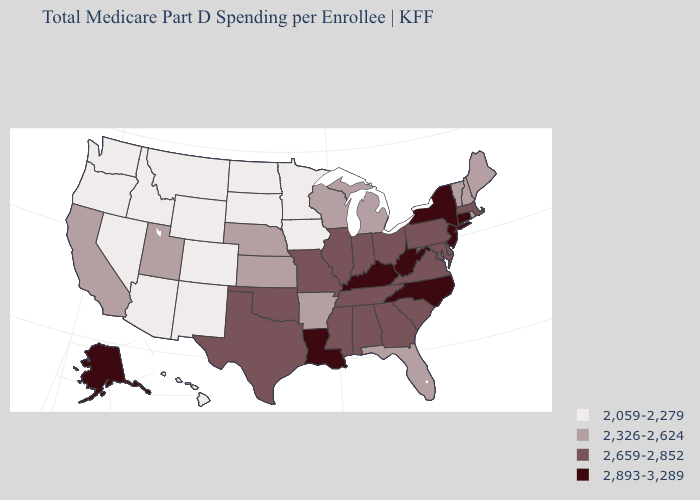Does Rhode Island have a higher value than North Dakota?
Give a very brief answer. Yes. What is the highest value in the USA?
Give a very brief answer. 2,893-3,289. Which states have the lowest value in the South?
Be succinct. Arkansas, Florida. Among the states that border Maryland , does Pennsylvania have the highest value?
Answer briefly. No. What is the value of Montana?
Keep it brief. 2,059-2,279. What is the highest value in states that border Virginia?
Answer briefly. 2,893-3,289. Does Louisiana have the same value as New Jersey?
Answer briefly. Yes. What is the highest value in states that border Ohio?
Give a very brief answer. 2,893-3,289. What is the value of Rhode Island?
Quick response, please. 2,326-2,624. Name the states that have a value in the range 2,059-2,279?
Write a very short answer. Arizona, Colorado, Hawaii, Idaho, Iowa, Minnesota, Montana, Nevada, New Mexico, North Dakota, Oregon, South Dakota, Washington, Wyoming. What is the lowest value in the West?
Quick response, please. 2,059-2,279. What is the lowest value in the USA?
Short answer required. 2,059-2,279. Does New Jersey have the same value as Tennessee?
Short answer required. No. What is the value of Florida?
Write a very short answer. 2,326-2,624. Name the states that have a value in the range 2,893-3,289?
Give a very brief answer. Alaska, Connecticut, Kentucky, Louisiana, New Jersey, New York, North Carolina, West Virginia. 